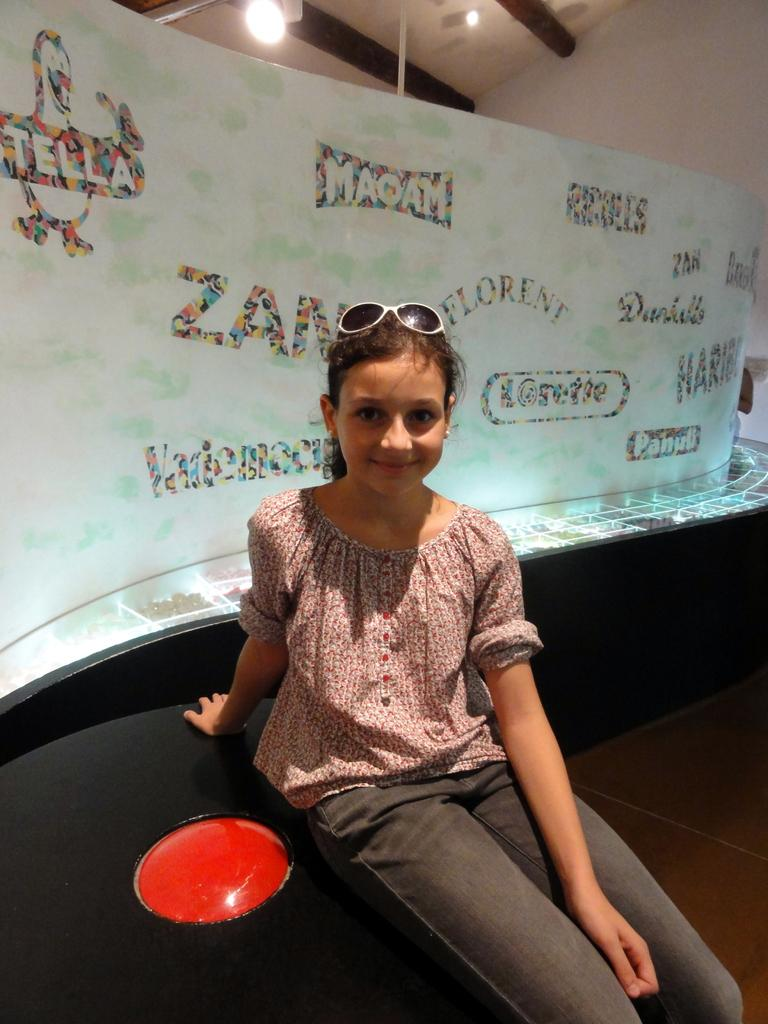What is the girl doing in the image? The girl is sitting on an object in the image. What can be seen in the background behind the girl? There is a board with text and figures, as well as a wall, visible in the background. Can you describe the lighting in the image? There is a light visible in the image. What type of suit is the laborer wearing in the image? There is no laborer or suit present in the image. What subject is being taught in the school depicted in the image? There is no school depicted in the image. 